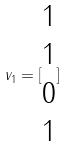<formula> <loc_0><loc_0><loc_500><loc_500>v _ { 1 } = [ \begin{matrix} 1 \\ 1 \\ 0 \\ 1 \end{matrix} ]</formula> 